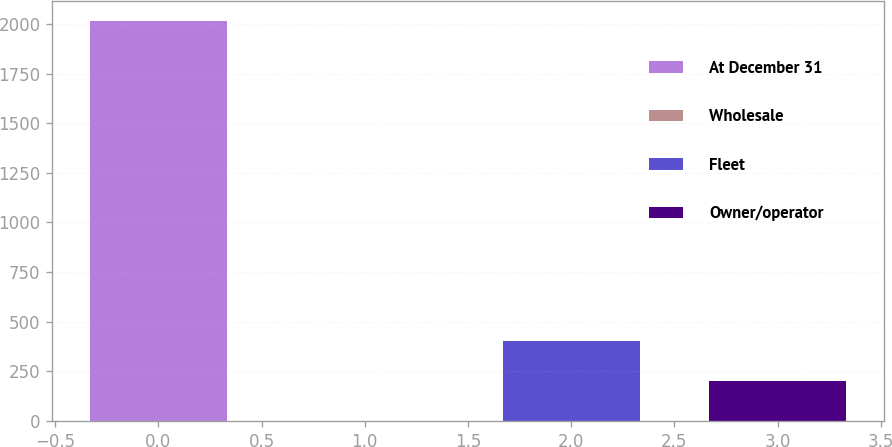Convert chart to OTSL. <chart><loc_0><loc_0><loc_500><loc_500><bar_chart><fcel>At December 31<fcel>Wholesale<fcel>Fleet<fcel>Owner/operator<nl><fcel>2016<fcel>0.1<fcel>403.28<fcel>201.69<nl></chart> 